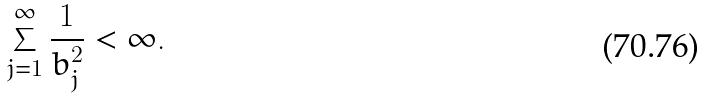Convert formula to latex. <formula><loc_0><loc_0><loc_500><loc_500>\sum _ { j = 1 } ^ { \infty } \frac { 1 } { b _ { j } ^ { 2 } } < \infty .</formula> 